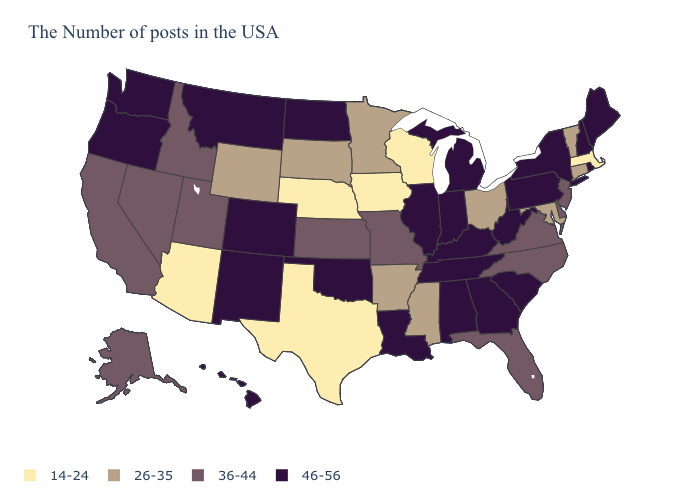What is the highest value in states that border New Hampshire?
Answer briefly. 46-56. Among the states that border Virginia , which have the highest value?
Short answer required. West Virginia, Kentucky, Tennessee. Which states have the lowest value in the South?
Short answer required. Texas. Among the states that border South Carolina , which have the lowest value?
Concise answer only. North Carolina. Which states hav the highest value in the MidWest?
Write a very short answer. Michigan, Indiana, Illinois, North Dakota. What is the lowest value in states that border Maine?
Be succinct. 46-56. Name the states that have a value in the range 46-56?
Quick response, please. Maine, Rhode Island, New Hampshire, New York, Pennsylvania, South Carolina, West Virginia, Georgia, Michigan, Kentucky, Indiana, Alabama, Tennessee, Illinois, Louisiana, Oklahoma, North Dakota, Colorado, New Mexico, Montana, Washington, Oregon, Hawaii. Among the states that border Missouri , which have the highest value?
Short answer required. Kentucky, Tennessee, Illinois, Oklahoma. Name the states that have a value in the range 36-44?
Write a very short answer. New Jersey, Delaware, Virginia, North Carolina, Florida, Missouri, Kansas, Utah, Idaho, Nevada, California, Alaska. What is the value of Florida?
Keep it brief. 36-44. Does Vermont have the lowest value in the Northeast?
Quick response, please. No. What is the value of Utah?
Write a very short answer. 36-44. Among the states that border Georgia , does Alabama have the highest value?
Answer briefly. Yes. What is the value of Iowa?
Quick response, please. 14-24. Among the states that border West Virginia , which have the highest value?
Be succinct. Pennsylvania, Kentucky. 